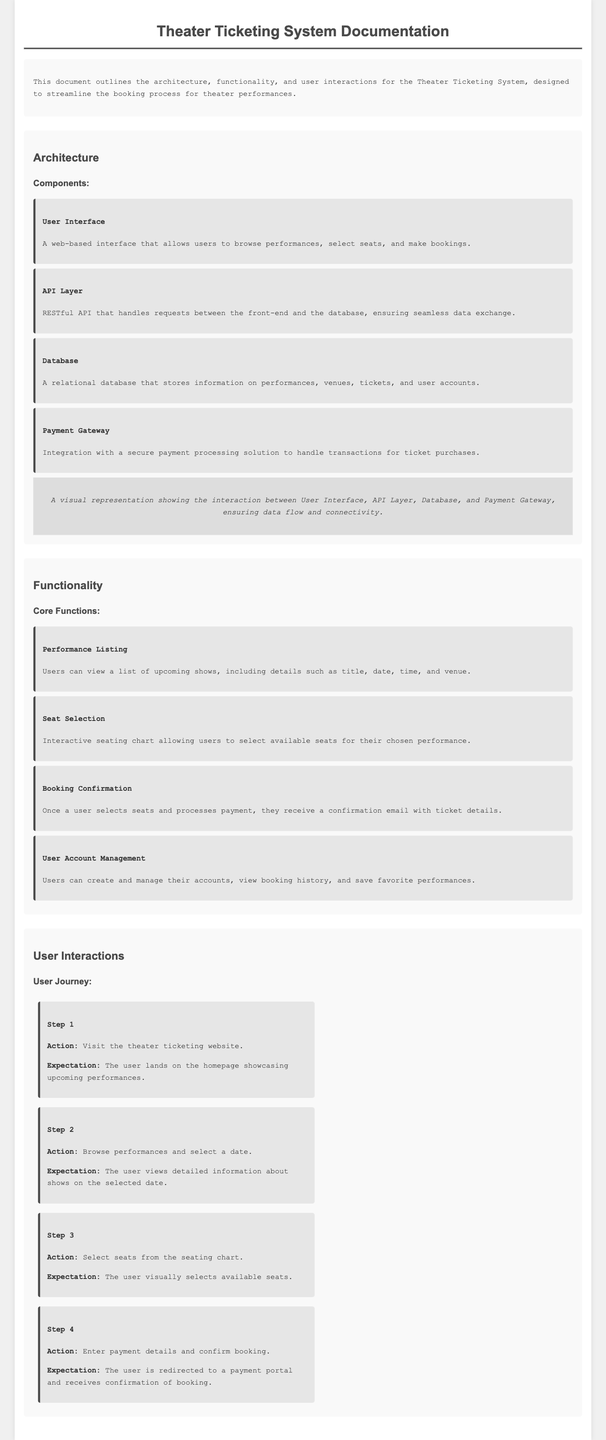what is the title of the document? The title of the document is presented in the header, which is “Theater Ticketing System Documentation.”
Answer: Theater Ticketing System Documentation how many core functions are listed in the functionality section? The number of core functions is indicated in the functionality section where four functions are outlined.
Answer: 4 what is the first action a user takes in the user journey? The first action is detailed in Step 1 of the user journey, which is visiting the theater ticketing website.
Answer: Visit the theater ticketing website what component handles requests between the front-end and the database? The document states that the API Layer is responsible for handling requests between the front-end and the database.
Answer: API Layer what happens once a user processes payment for a booking? The functionality section explains that the user receives a confirmation email with ticket details after processing payment.
Answer: Confirmation email with ticket details how is the user interface described in the architecture section? The user interface is described as a web-based interface that allows users to browse performances, select seats, and make bookings.
Answer: A web-based interface what is the background color of the document? The background color of the document is specified in the CSS styles as light grey.
Answer: #f0f0f0 what is the role of the payment gateway in the application? The payment gateway's role is stated as integration with a secure payment processing solution to handle transactions for ticket purchases.
Answer: Handle transactions for ticket purchases what does the user expect after selecting seats and confirming the booking? The expectation is to receive confirmation of the booking as stated in Step 4 of the user journey.
Answer: Confirmation of booking 